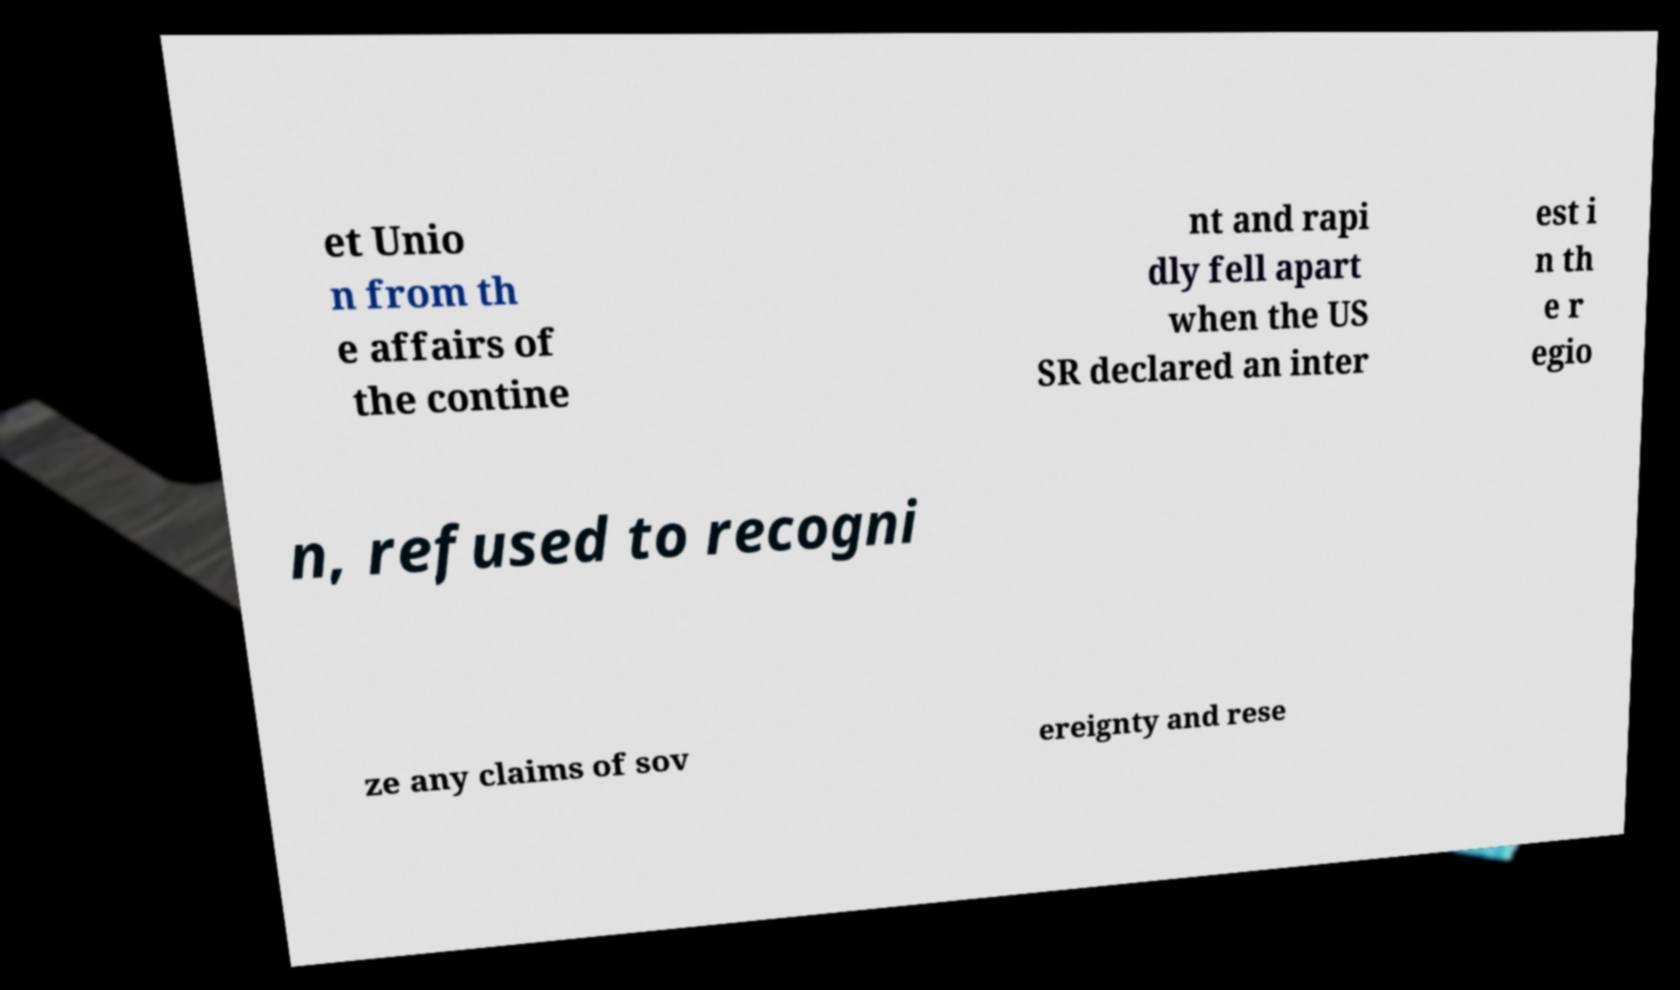What messages or text are displayed in this image? I need them in a readable, typed format. et Unio n from th e affairs of the contine nt and rapi dly fell apart when the US SR declared an inter est i n th e r egio n, refused to recogni ze any claims of sov ereignty and rese 